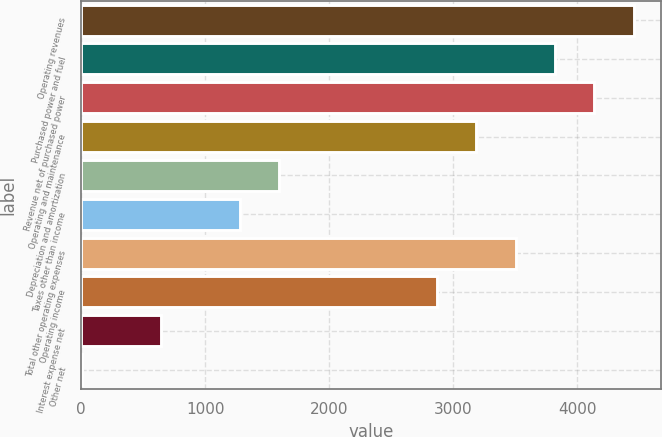<chart> <loc_0><loc_0><loc_500><loc_500><bar_chart><fcel>Operating revenues<fcel>Purchased power and fuel<fcel>Revenue net of purchased power<fcel>Operating and maintenance<fcel>Depreciation and amortization<fcel>Taxes other than income<fcel>Total other operating expenses<fcel>Operating income<fcel>Interest expense net<fcel>Other net<nl><fcel>4457.2<fcel>3821.6<fcel>4139.4<fcel>3186<fcel>1597<fcel>1279.2<fcel>3503.8<fcel>2868.2<fcel>643.6<fcel>8<nl></chart> 